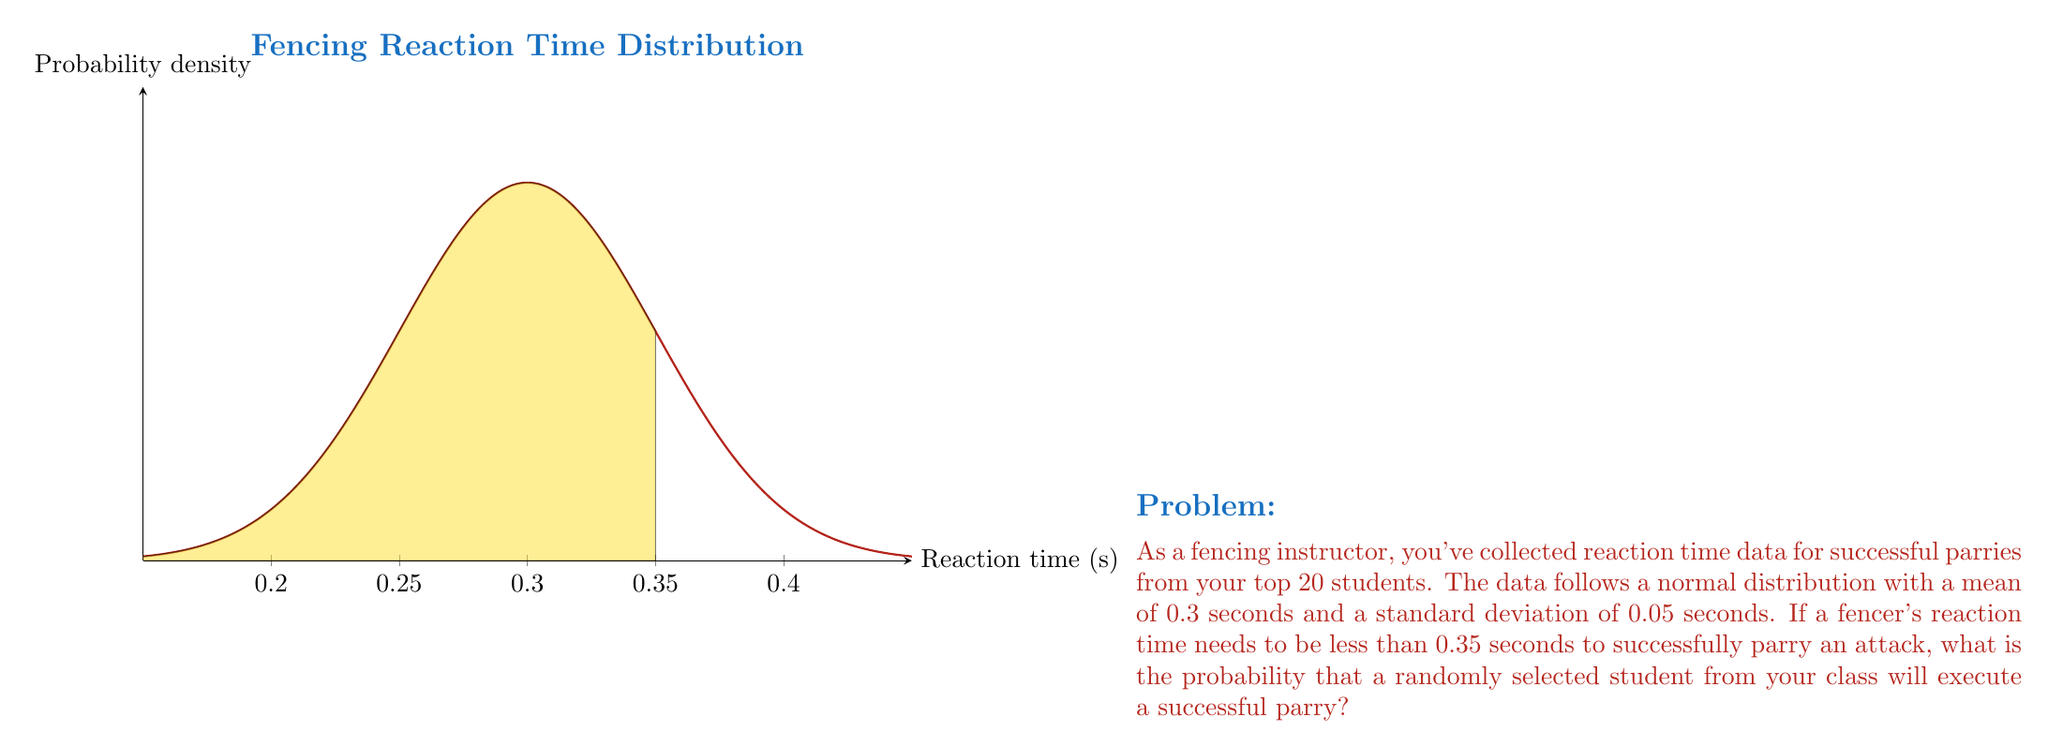Provide a solution to this math problem. Let's approach this step-by-step:

1) We're dealing with a normal distribution where:
   $\mu = 0.3$ seconds (mean)
   $\sigma = 0.05$ seconds (standard deviation)

2) We want to find the probability that a student's reaction time is less than 0.35 seconds.

3) To solve this, we need to calculate the z-score for 0.35 seconds:

   $$z = \frac{x - \mu}{\sigma} = \frac{0.35 - 0.3}{0.05} = 1$$

4) Now, we need to find the probability that a value is less than z = 1 in a standard normal distribution.

5) Using a standard normal distribution table or calculator, we find:

   $$P(Z < 1) \approx 0.8413$$

6) This means that approximately 84.13% of the values in the distribution are less than 0.35 seconds.

Therefore, the probability that a randomly selected student will execute a successful parry is about 0.8413 or 84.13%.
Answer: 0.8413 